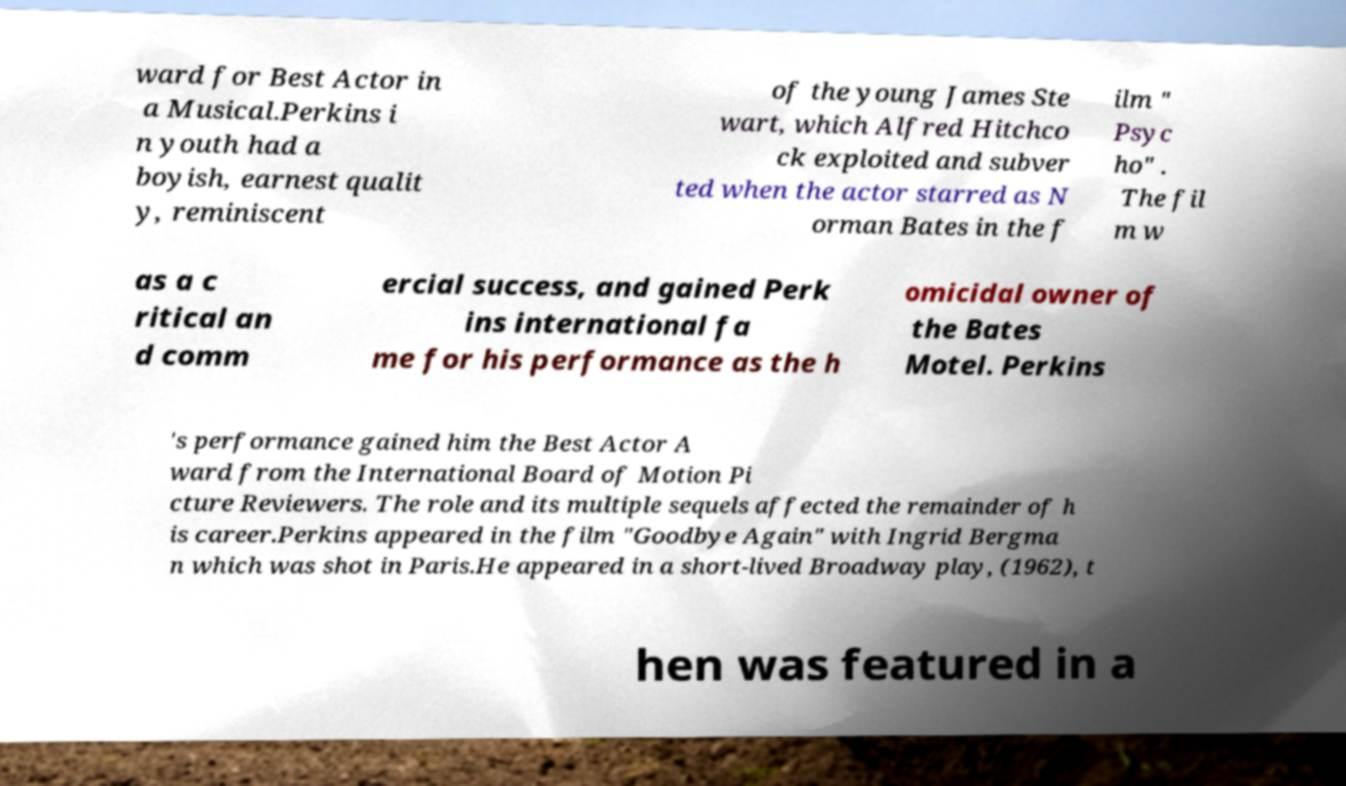What messages or text are displayed in this image? I need them in a readable, typed format. ward for Best Actor in a Musical.Perkins i n youth had a boyish, earnest qualit y, reminiscent of the young James Ste wart, which Alfred Hitchco ck exploited and subver ted when the actor starred as N orman Bates in the f ilm " Psyc ho" . The fil m w as a c ritical an d comm ercial success, and gained Perk ins international fa me for his performance as the h omicidal owner of the Bates Motel. Perkins 's performance gained him the Best Actor A ward from the International Board of Motion Pi cture Reviewers. The role and its multiple sequels affected the remainder of h is career.Perkins appeared in the film "Goodbye Again" with Ingrid Bergma n which was shot in Paris.He appeared in a short-lived Broadway play, (1962), t hen was featured in a 